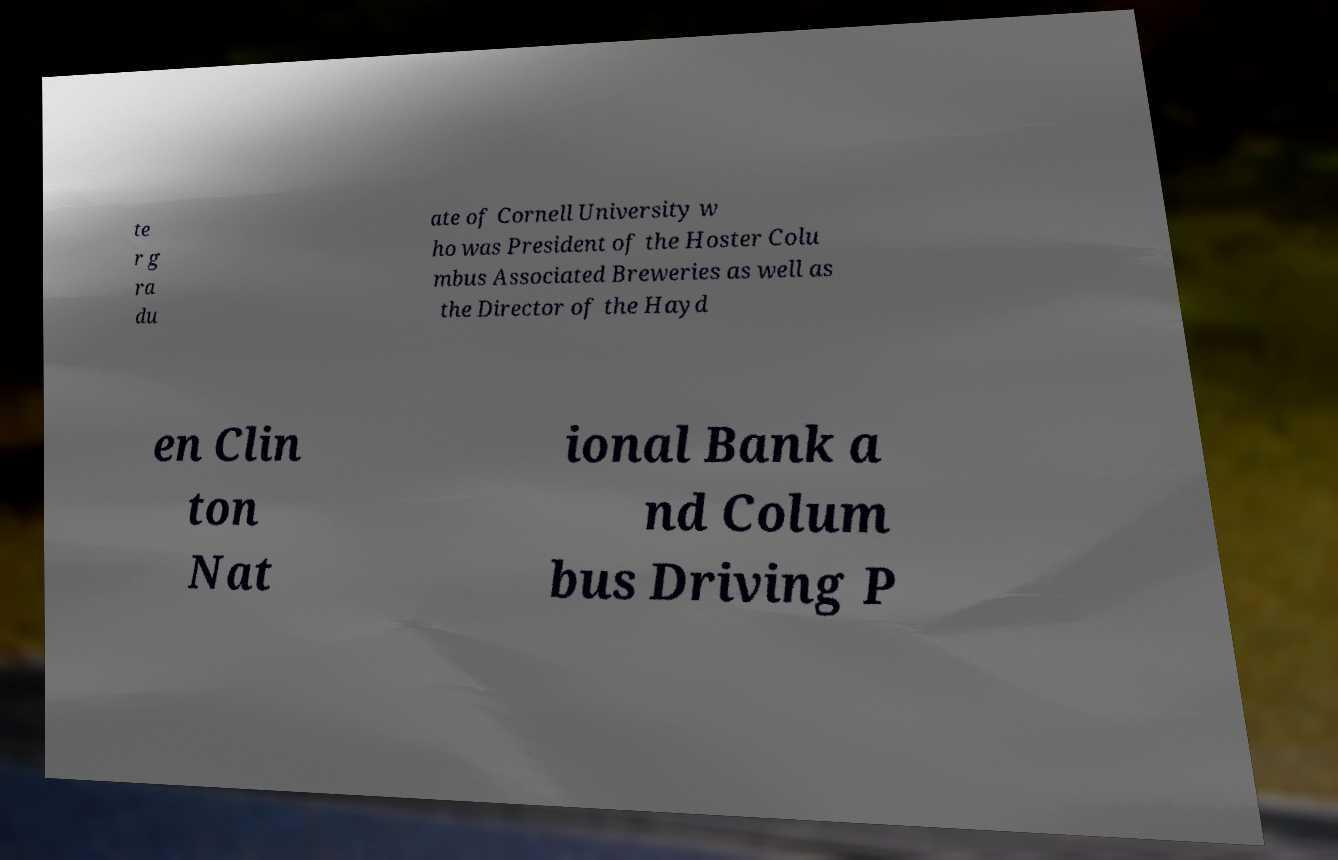Can you read and provide the text displayed in the image?This photo seems to have some interesting text. Can you extract and type it out for me? te r g ra du ate of Cornell University w ho was President of the Hoster Colu mbus Associated Breweries as well as the Director of the Hayd en Clin ton Nat ional Bank a nd Colum bus Driving P 